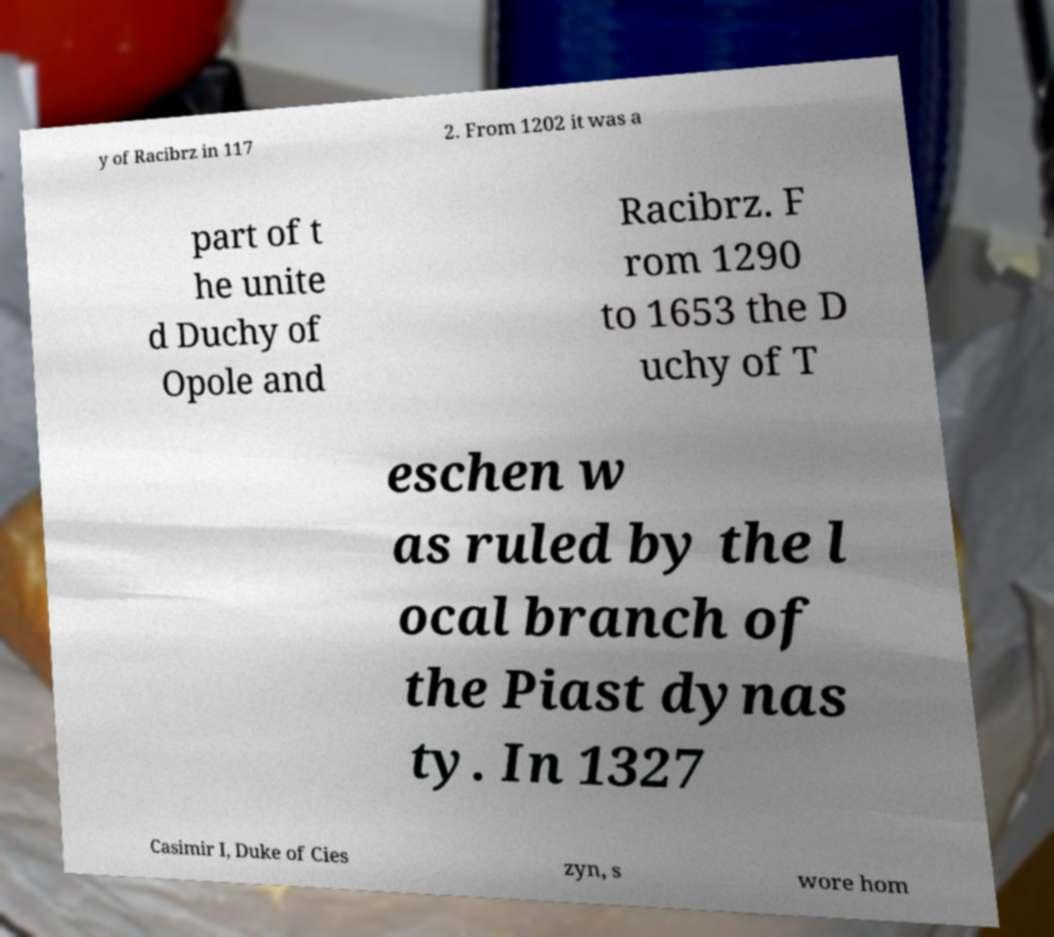Could you extract and type out the text from this image? y of Racibrz in 117 2. From 1202 it was a part of t he unite d Duchy of Opole and Racibrz. F rom 1290 to 1653 the D uchy of T eschen w as ruled by the l ocal branch of the Piast dynas ty. In 1327 Casimir I, Duke of Cies zyn, s wore hom 